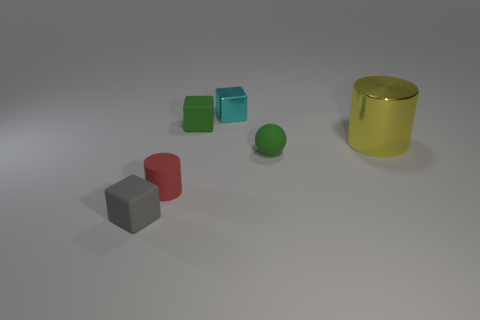Subtract all tiny cyan cubes. How many cubes are left? 2 Add 4 small green rubber balls. How many objects exist? 10 Subtract all yellow things. Subtract all small matte cylinders. How many objects are left? 4 Add 6 yellow shiny objects. How many yellow shiny objects are left? 7 Add 6 tiny green things. How many tiny green things exist? 8 Subtract 0 blue cubes. How many objects are left? 6 Subtract all cylinders. How many objects are left? 4 